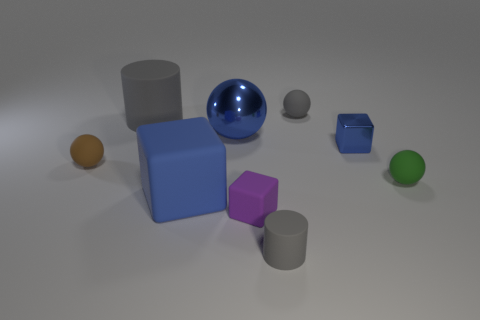There is a ball that is both in front of the metal block and on the left side of the purple matte cube; what is its color?
Give a very brief answer. Brown. What number of things are big spheres or spheres right of the large sphere?
Offer a terse response. 3. There is a big blue object that is in front of the rubber thing to the right of the small gray rubber thing right of the small matte cylinder; what is it made of?
Offer a terse response. Rubber. Are there any other things that have the same material as the purple block?
Offer a very short reply. Yes. There is a tiny sphere behind the blue metallic sphere; is its color the same as the tiny shiny cube?
Your answer should be very brief. No. How many green things are matte cubes or large cubes?
Give a very brief answer. 0. What number of other things are there of the same shape as the small brown matte thing?
Provide a short and direct response. 3. Are the gray sphere and the purple cube made of the same material?
Ensure brevity in your answer.  Yes. There is a small thing that is on the left side of the tiny matte cylinder and behind the purple cube; what is its material?
Make the answer very short. Rubber. The cylinder to the left of the tiny purple thing is what color?
Provide a short and direct response. Gray. 